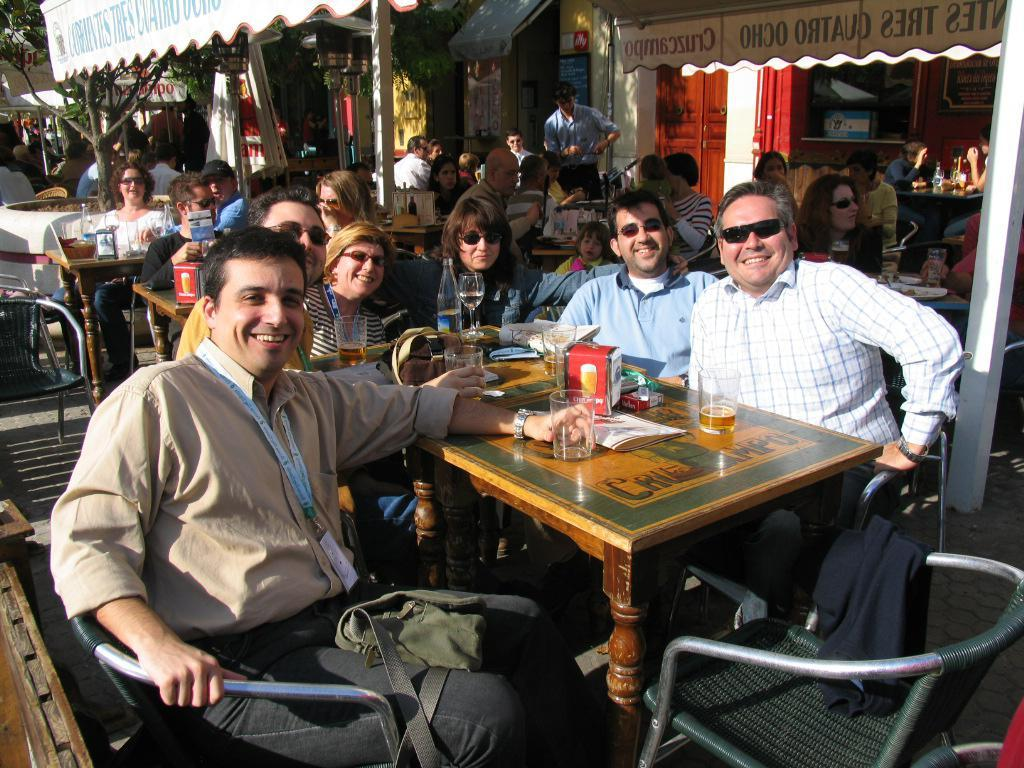What is happening in the image? There is a group of people in the image, and they are sitting. What are the people holding in their hands? The people are holding wine glasses in their hands. Are there any beds visible in the image? No, there are no beds present in the image. Is anyone wearing a mask in the image? No, there is no mention of anyone wearing a mask in the image. 